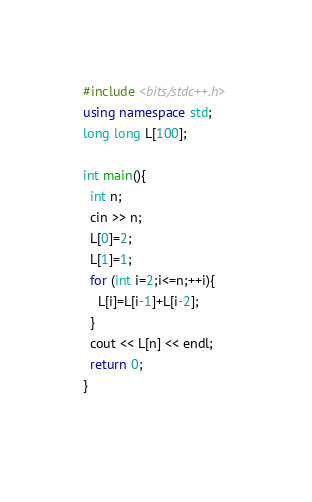Convert code to text. <code><loc_0><loc_0><loc_500><loc_500><_C++_>#include <bits/stdc++.h>
using namespace std;
long long L[100];

int main(){
  int n;
  cin >> n;
  L[0]=2;
  L[1]=1;
  for (int i=2;i<=n;++i){
    L[i]=L[i-1]+L[i-2];
  }
  cout << L[n] << endl;
  return 0;
}
  
</code> 